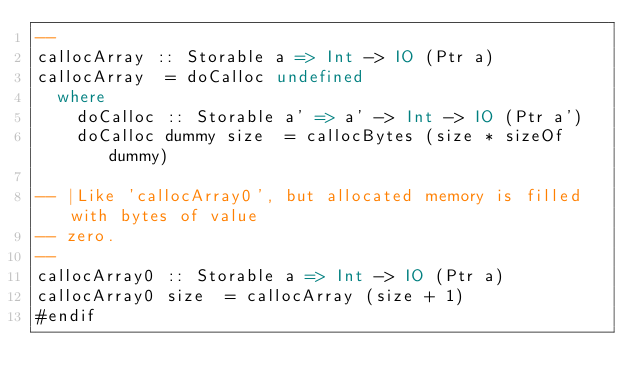Convert code to text. <code><loc_0><loc_0><loc_500><loc_500><_Haskell_>--
callocArray :: Storable a => Int -> IO (Ptr a)
callocArray  = doCalloc undefined
  where
    doCalloc :: Storable a' => a' -> Int -> IO (Ptr a')
    doCalloc dummy size  = callocBytes (size * sizeOf dummy)

-- |Like 'callocArray0', but allocated memory is filled with bytes of value
-- zero.
--
callocArray0 :: Storable a => Int -> IO (Ptr a)
callocArray0 size  = callocArray (size + 1)
#endif
</code> 